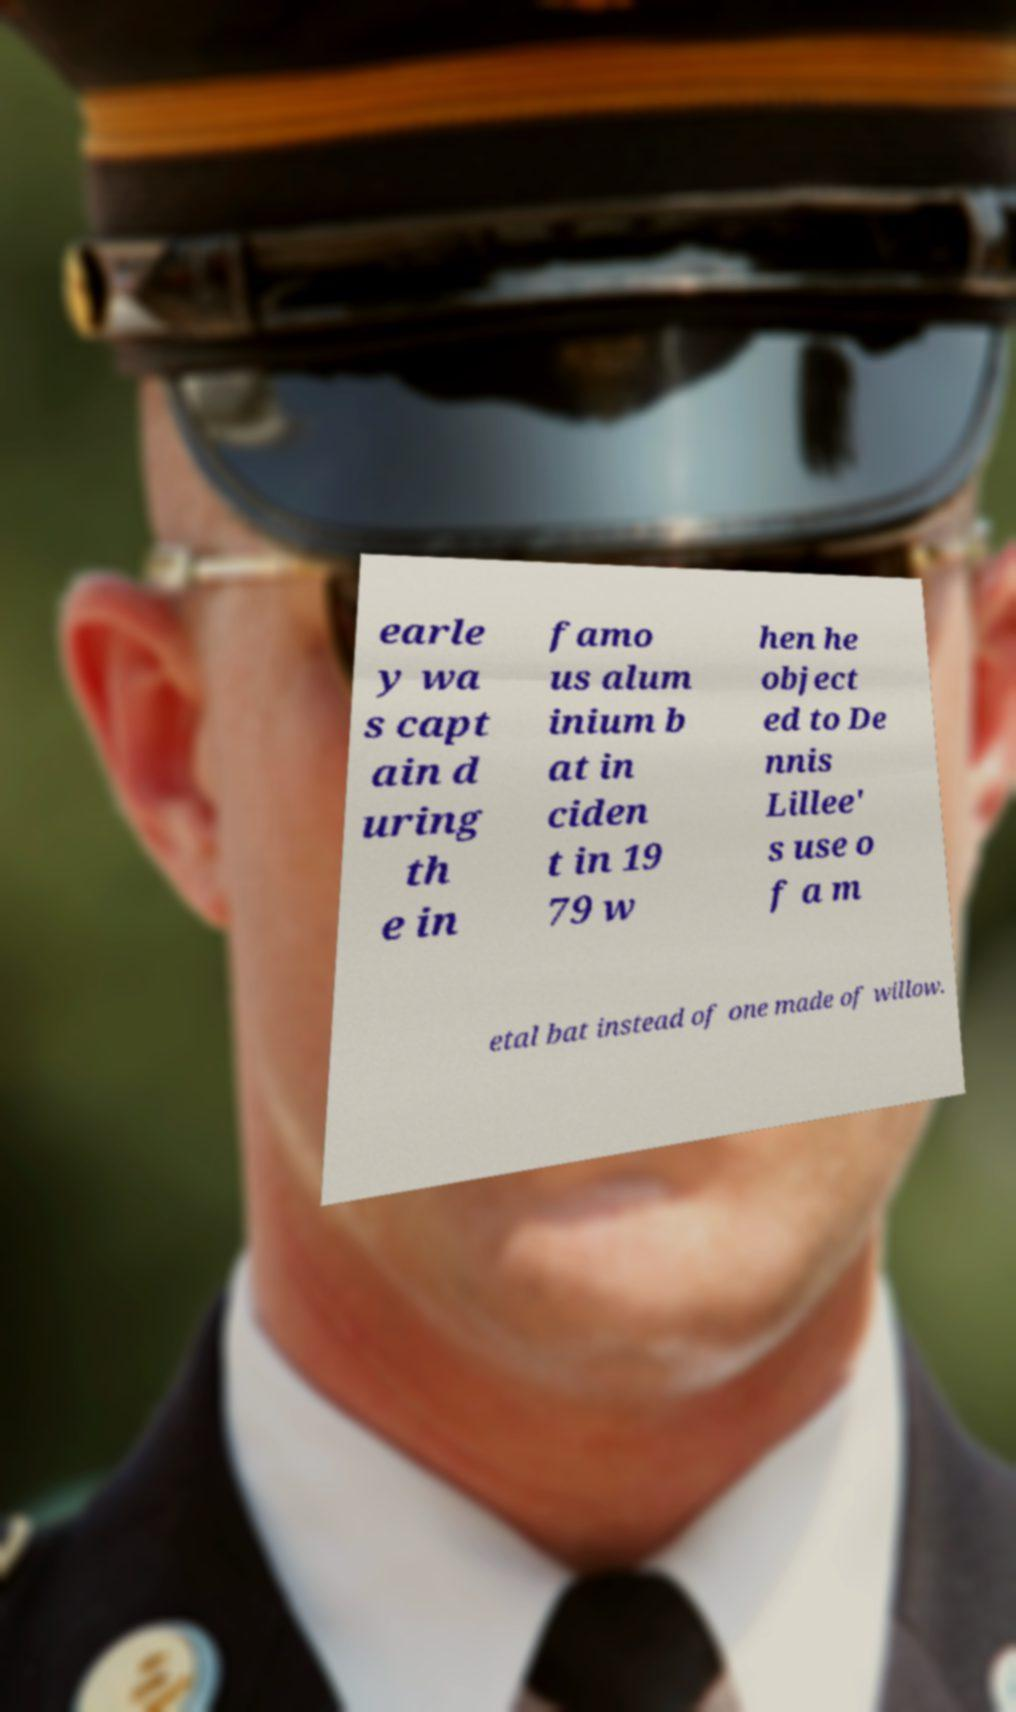Can you accurately transcribe the text from the provided image for me? earle y wa s capt ain d uring th e in famo us alum inium b at in ciden t in 19 79 w hen he object ed to De nnis Lillee' s use o f a m etal bat instead of one made of willow. 